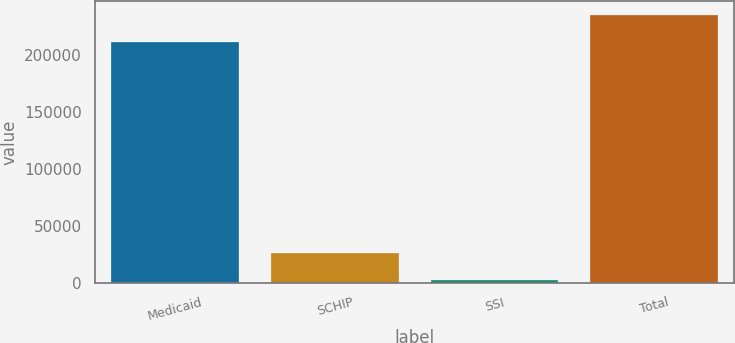Convert chart. <chart><loc_0><loc_0><loc_500><loc_500><bar_chart><fcel>Medicaid<fcel>SCHIP<fcel>SSI<fcel>Total<nl><fcel>210900<fcel>25670<fcel>2400<fcel>235100<nl></chart> 